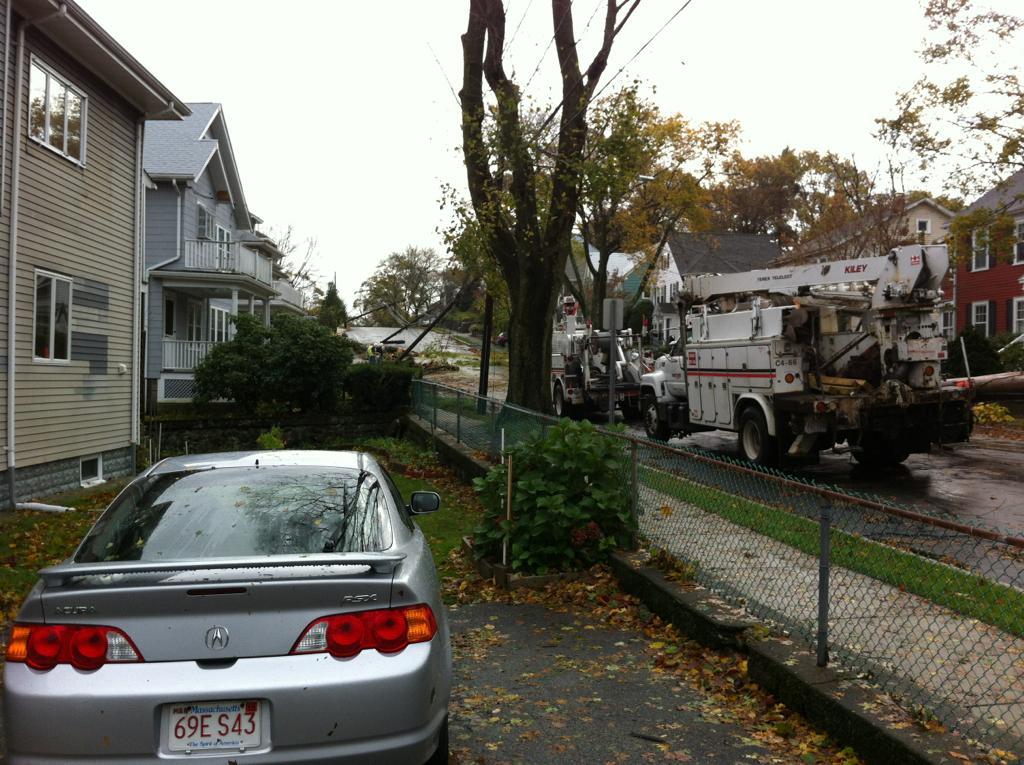In one or two sentences, can you explain what this image depicts? In this image we can see vehicles, trees and plants. Behind the vehicles we can see a few houses. At the top we can see the sky and wires. At the bottom we can see dried leaves. 